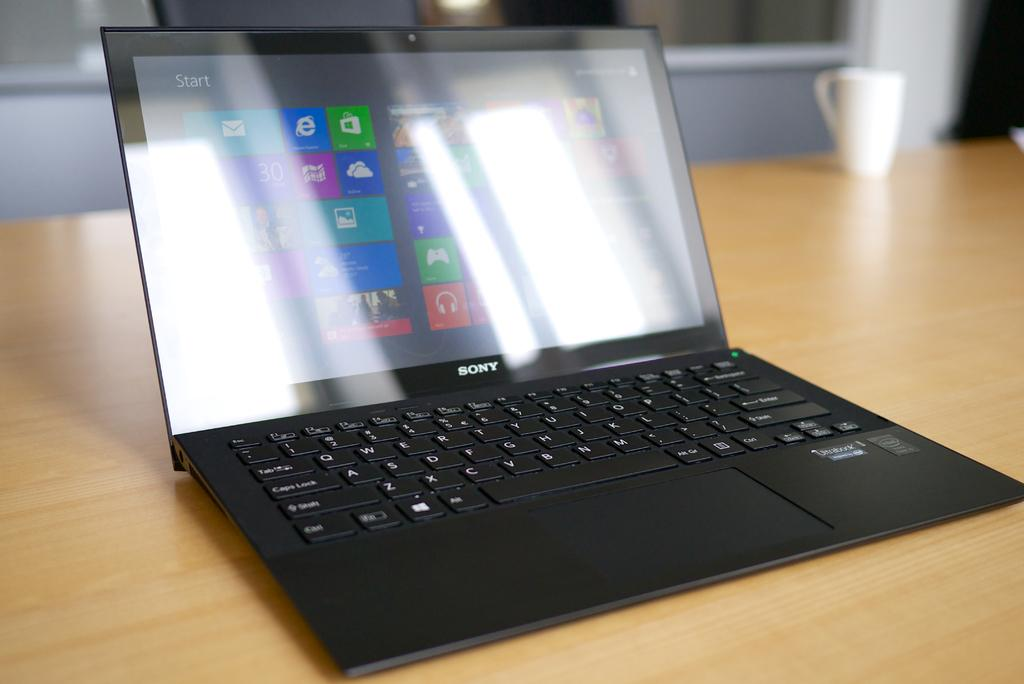What electronic device is visible in the image? There is a laptop in the image. Where is the laptop located? The laptop is placed on a table. What else can be seen on the table in the image? There is a cup placed on the table in the image. What type of wristwatch is visible on the laptop in the image? There is no wristwatch present on the laptop in the image. What kind of shoes are the people wearing in the image? There are no people visible in the image, so it is impossible to determine what type of shoes they might be wearing. 